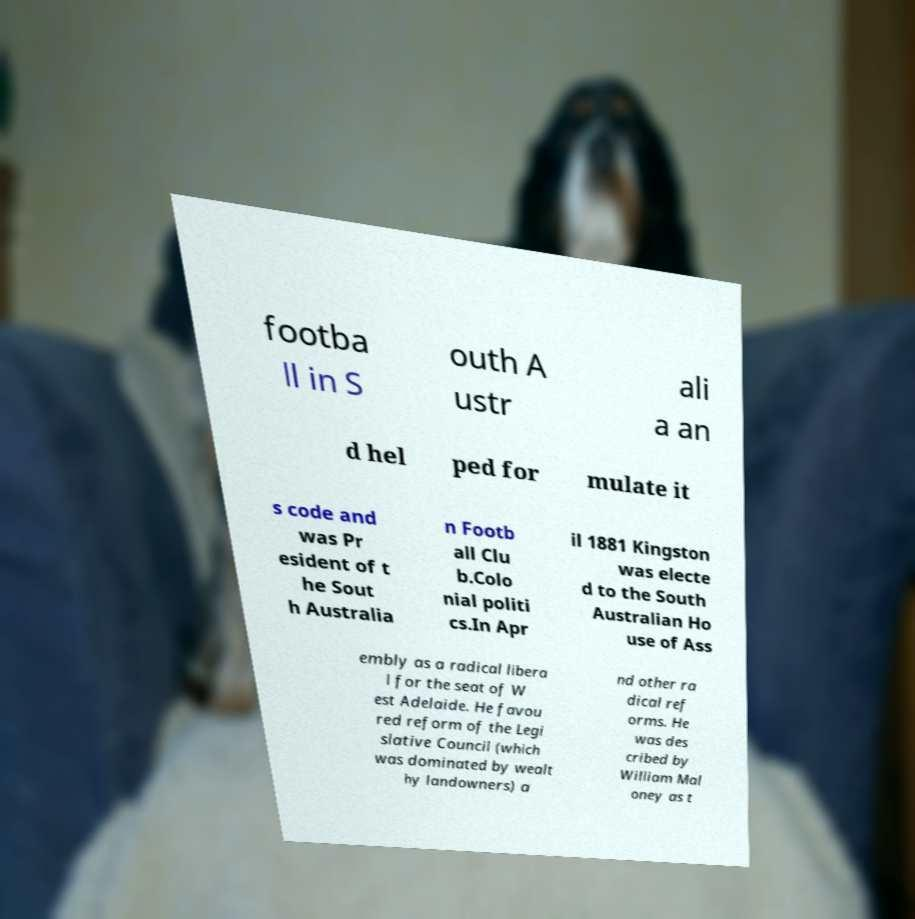For documentation purposes, I need the text within this image transcribed. Could you provide that? footba ll in S outh A ustr ali a an d hel ped for mulate it s code and was Pr esident of t he Sout h Australia n Footb all Clu b.Colo nial politi cs.In Apr il 1881 Kingston was electe d to the South Australian Ho use of Ass embly as a radical libera l for the seat of W est Adelaide. He favou red reform of the Legi slative Council (which was dominated by wealt hy landowners) a nd other ra dical ref orms. He was des cribed by William Mal oney as t 